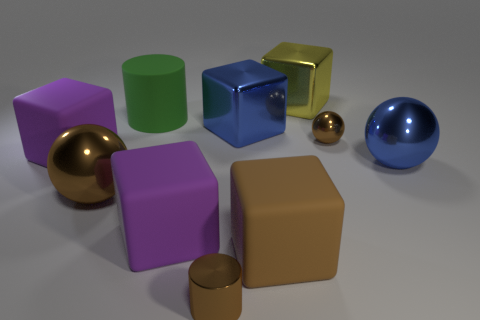Subtract all brown blocks. How many blocks are left? 4 Subtract all large blue shiny cubes. How many cubes are left? 4 Subtract 1 blocks. How many blocks are left? 4 Subtract all cyan cubes. Subtract all cyan balls. How many cubes are left? 5 Subtract all spheres. How many objects are left? 7 Add 3 brown matte cubes. How many brown matte cubes are left? 4 Add 7 large brown cubes. How many large brown cubes exist? 8 Subtract 0 red cylinders. How many objects are left? 10 Subtract all yellow metal objects. Subtract all small gray spheres. How many objects are left? 9 